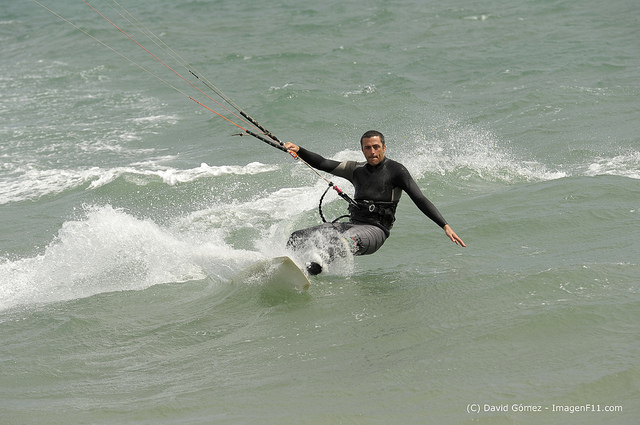Identify and read out the text in this image. c David Gomez ImagenF11.com 